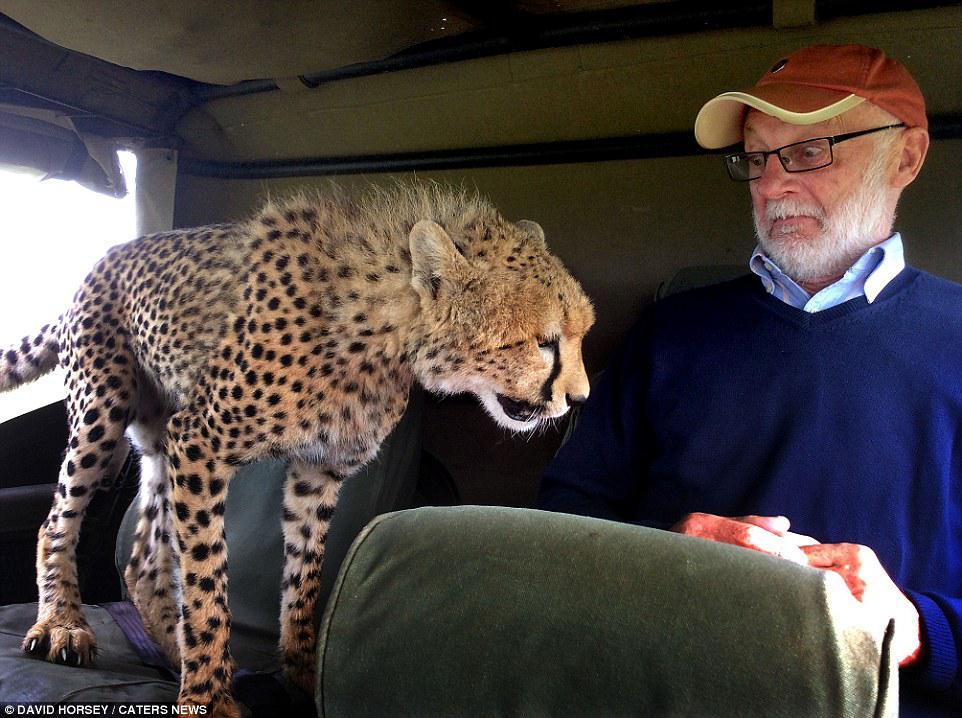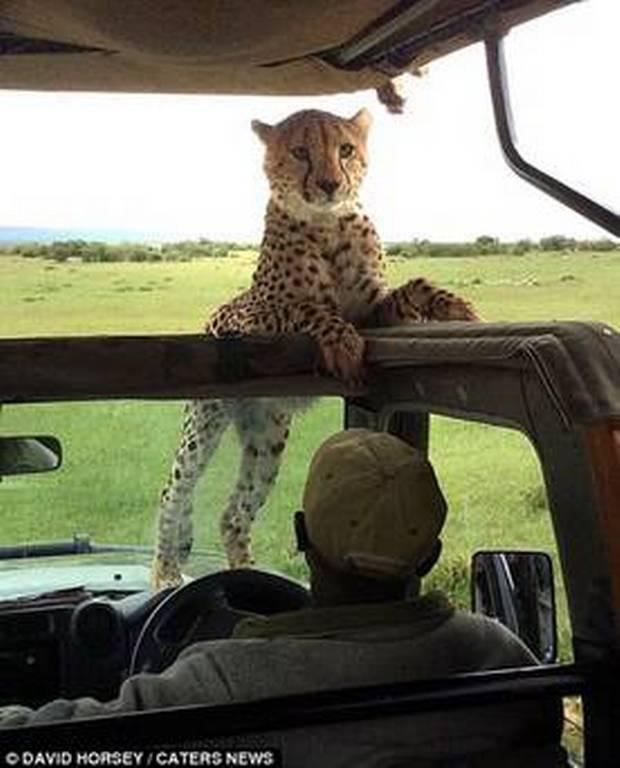The first image is the image on the left, the second image is the image on the right. Given the left and right images, does the statement "The left image shows a cheetah inside a vehicle perched on the back seat, and the right image shows a cheetah with its body facing the camera, draping its front paws over part of the vehicle's frame." hold true? Answer yes or no. Yes. The first image is the image on the left, the second image is the image on the right. Examine the images to the left and right. Is the description "In one image, a cheetah is on a seat in the vehicle." accurate? Answer yes or no. Yes. 